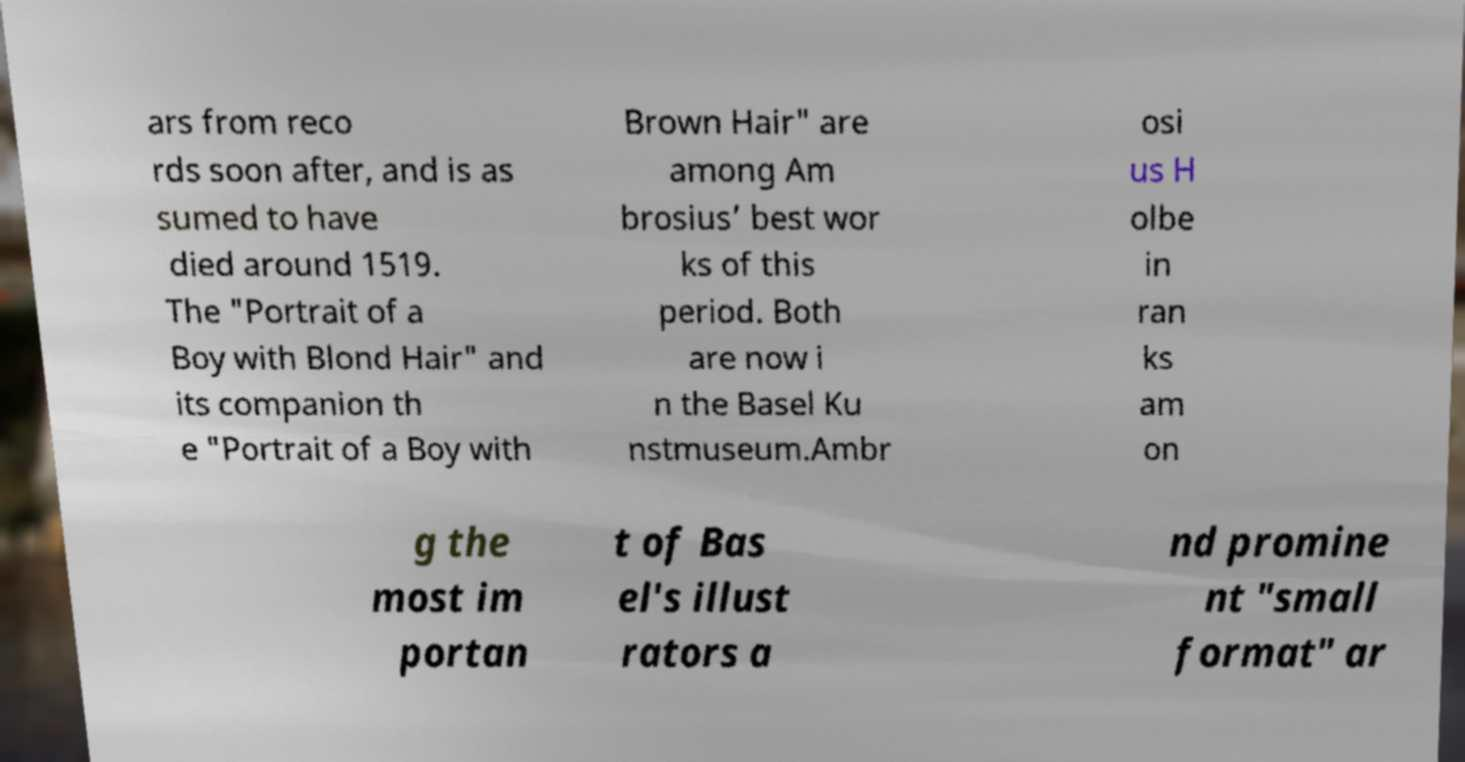Could you assist in decoding the text presented in this image and type it out clearly? ars from reco rds soon after, and is as sumed to have died around 1519. The "Portrait of a Boy with Blond Hair" and its companion th e "Portrait of a Boy with Brown Hair" are among Am brosius’ best wor ks of this period. Both are now i n the Basel Ku nstmuseum.Ambr osi us H olbe in ran ks am on g the most im portan t of Bas el's illust rators a nd promine nt "small format" ar 